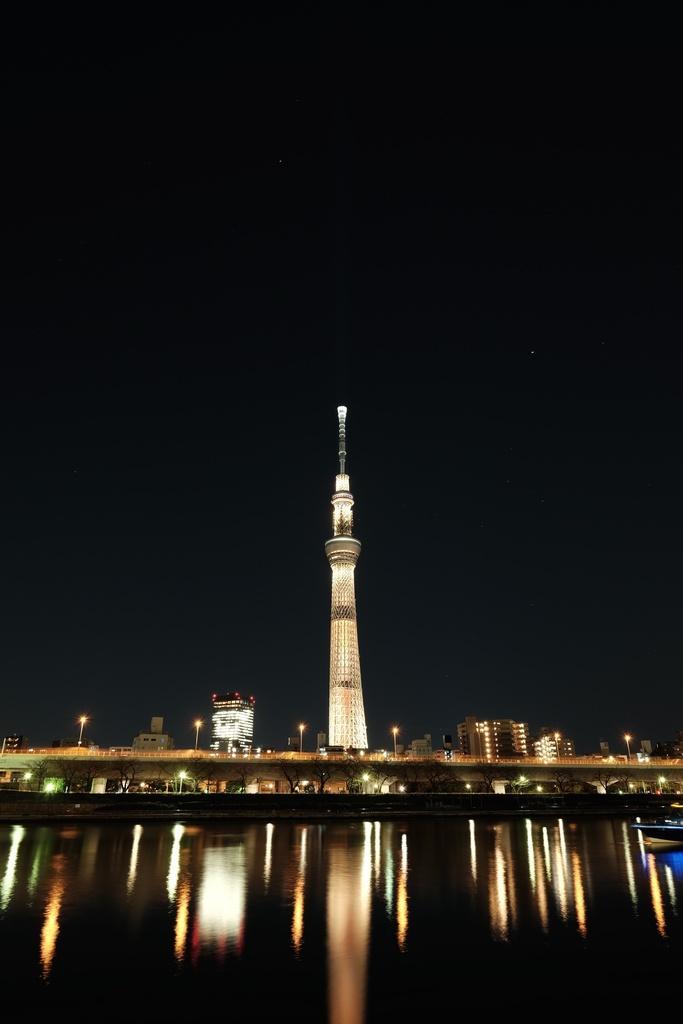How would you summarize this image in a sentence or two? In this image in the center there is one tower, and on the right side and left side there are some buildings. At the bottom there is a river and some lights, at the top there is sky. 